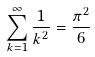<formula> <loc_0><loc_0><loc_500><loc_500>\sum _ { k = 1 } ^ { \infty } \frac { 1 } { k ^ { 2 } } = \frac { \pi ^ { 2 } } { 6 }</formula> 